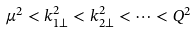Convert formula to latex. <formula><loc_0><loc_0><loc_500><loc_500>\mu ^ { 2 } < k ^ { 2 } _ { 1 \perp } < k ^ { 2 } _ { 2 \perp } < \dots < Q ^ { 2 }</formula> 